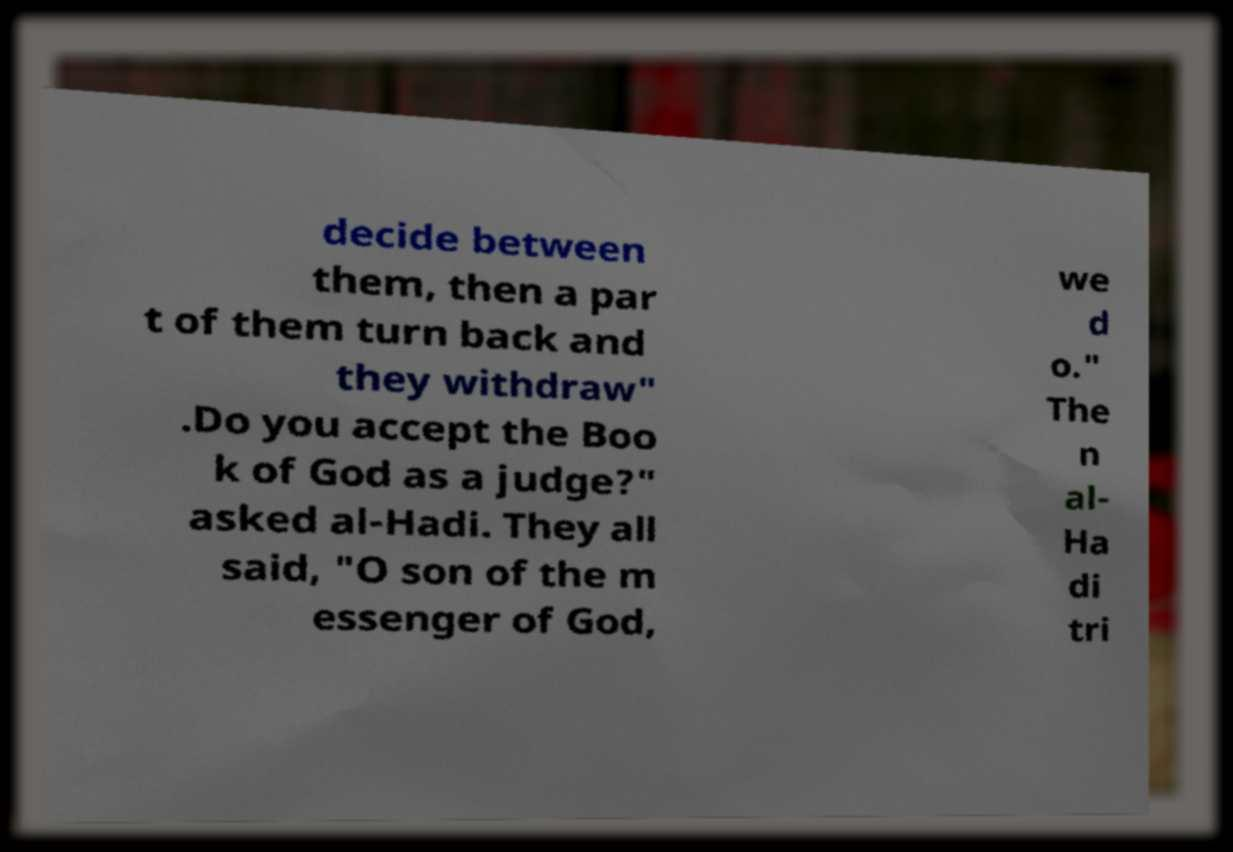What messages or text are displayed in this image? I need them in a readable, typed format. decide between them, then a par t of them turn back and they withdraw" .Do you accept the Boo k of God as a judge?" asked al-Hadi. They all said, "O son of the m essenger of God, we d o." The n al- Ha di tri 